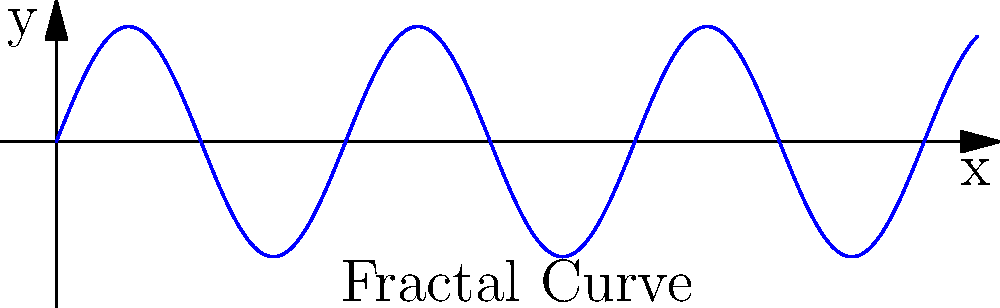In analyzing the YouTuber's use of fractals for creating intricate animated landscapes, consider the curve shown above. If this curve were to be recursively applied to itself at increasingly smaller scales, what geometric property would emerge that is characteristic of fractal-based animations? To understand the fractal nature of this curve and its application in animation, let's break it down step-by-step:

1. The given curve is a sinusoidal function, represented by $f(x) = 0.5 \sin(5x)$.

2. In fractal geometry, self-similarity is a key concept. This means that the same pattern repeats at different scales.

3. If we were to apply this curve recursively to itself at smaller scales, we would:
   a. Take each segment of the curve
   b. Replace it with a scaled-down version of the entire curve
   c. Repeat this process indefinitely

4. As we continue this process, the curve would become increasingly complex, with more and more detail at smaller and smaller scales.

5. This property is known as infinite detail or infinite complexity. No matter how much you zoom in, you would always find more intricate patterns.

6. In animation, this property allows for the creation of highly detailed landscapes or textures that maintain their complexity regardless of the viewer's distance or perspective.

7. The resulting shape would exhibit fractional dimensionality, a characteristic of fractals that lies between traditional Euclidean dimensions.

8. This technique is particularly useful in creating natural-looking landscapes, as many natural phenomena (like coastlines, mountains, and clouds) exhibit fractal-like properties.
Answer: Self-similarity at infinite scales 